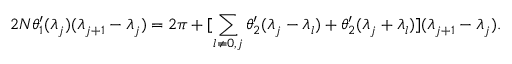<formula> <loc_0><loc_0><loc_500><loc_500>2 N \theta _ { 1 } ^ { \prime } ( \lambda _ { j } ) ( \lambda _ { j + 1 } - \lambda _ { j } ) = 2 \pi + [ \sum _ { l \neq 0 , j } \theta _ { 2 } ^ { \prime } ( \lambda _ { j } - \lambda _ { l } ) + \theta _ { 2 } ^ { \prime } ( \lambda _ { j } + \lambda _ { l } ) ] ( \lambda _ { j + 1 } - \lambda _ { j } ) .</formula> 